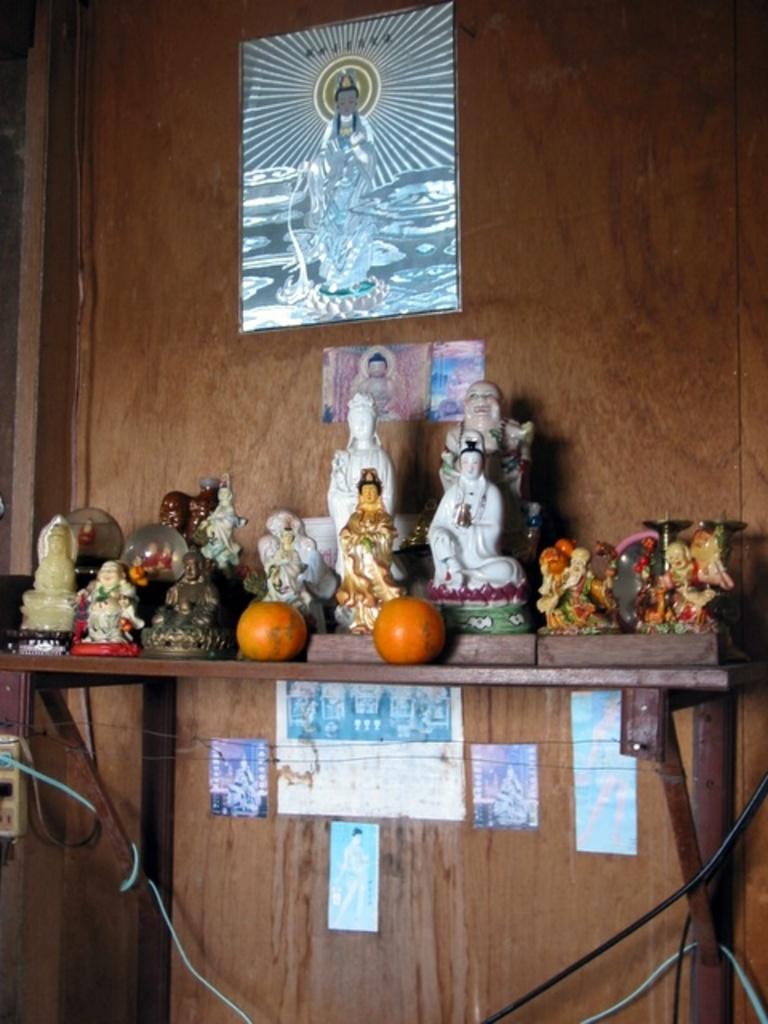What can be seen on stands in the image? There are statues on stands in the image. What is present on the wooden wall in the background of the image? There are posters on a wooden wall in the background of the image. What type of credit can be seen being given to the students in the image? There is no indication of students or credit being given in the image; it features statues on stands and posters on a wooden wall. 